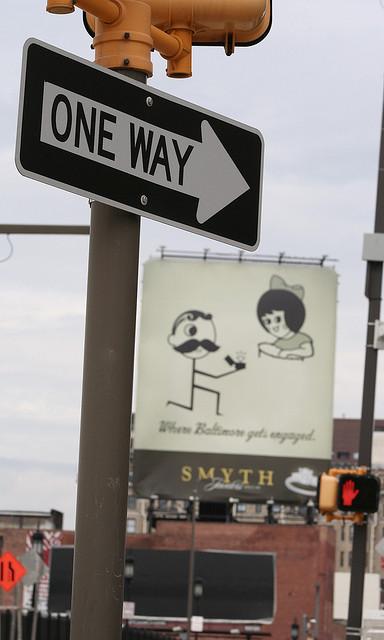What is the cartoon man presenting to the cartoon woman?
Write a very short answer. Ring. What color is the sign?
Give a very brief answer. Black and white. What does the sign with the white arrow say?
Keep it brief. One way. Which way can you not turn?
Concise answer only. Left. What is above the "No Left Turn" sign?
Quick response, please. One way. 